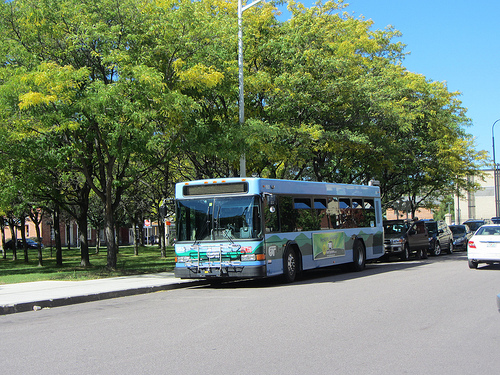Which kind of vehicle isn't blue? The car isn't blue; it appears to be of a different color. 